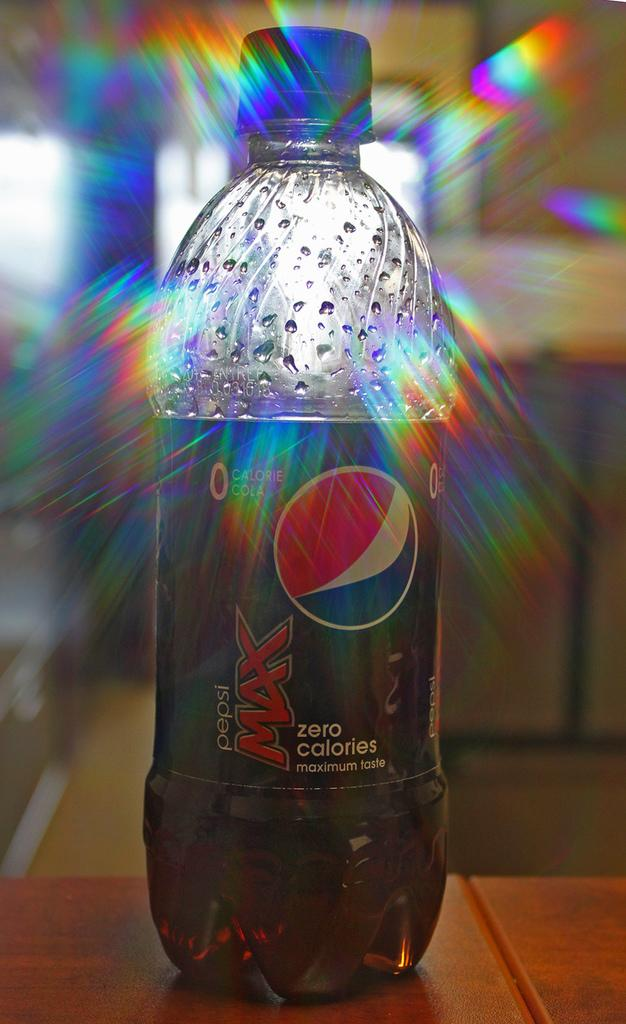What type of table is in the image? There is a wooden table in the image. What object is on the table? There is a Coca-Cola bottle on the table. How many islands can be seen in the image? There are no islands present in the image. What type of pail is used to collect water in the image? There is no pail present in the image. 